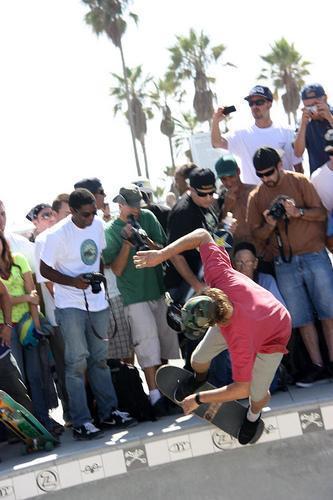What are people filming and taking pictures of?
From the following set of four choices, select the accurate answer to respond to the question.
Options: Accident, tricks, skateboards, model. Tricks. 